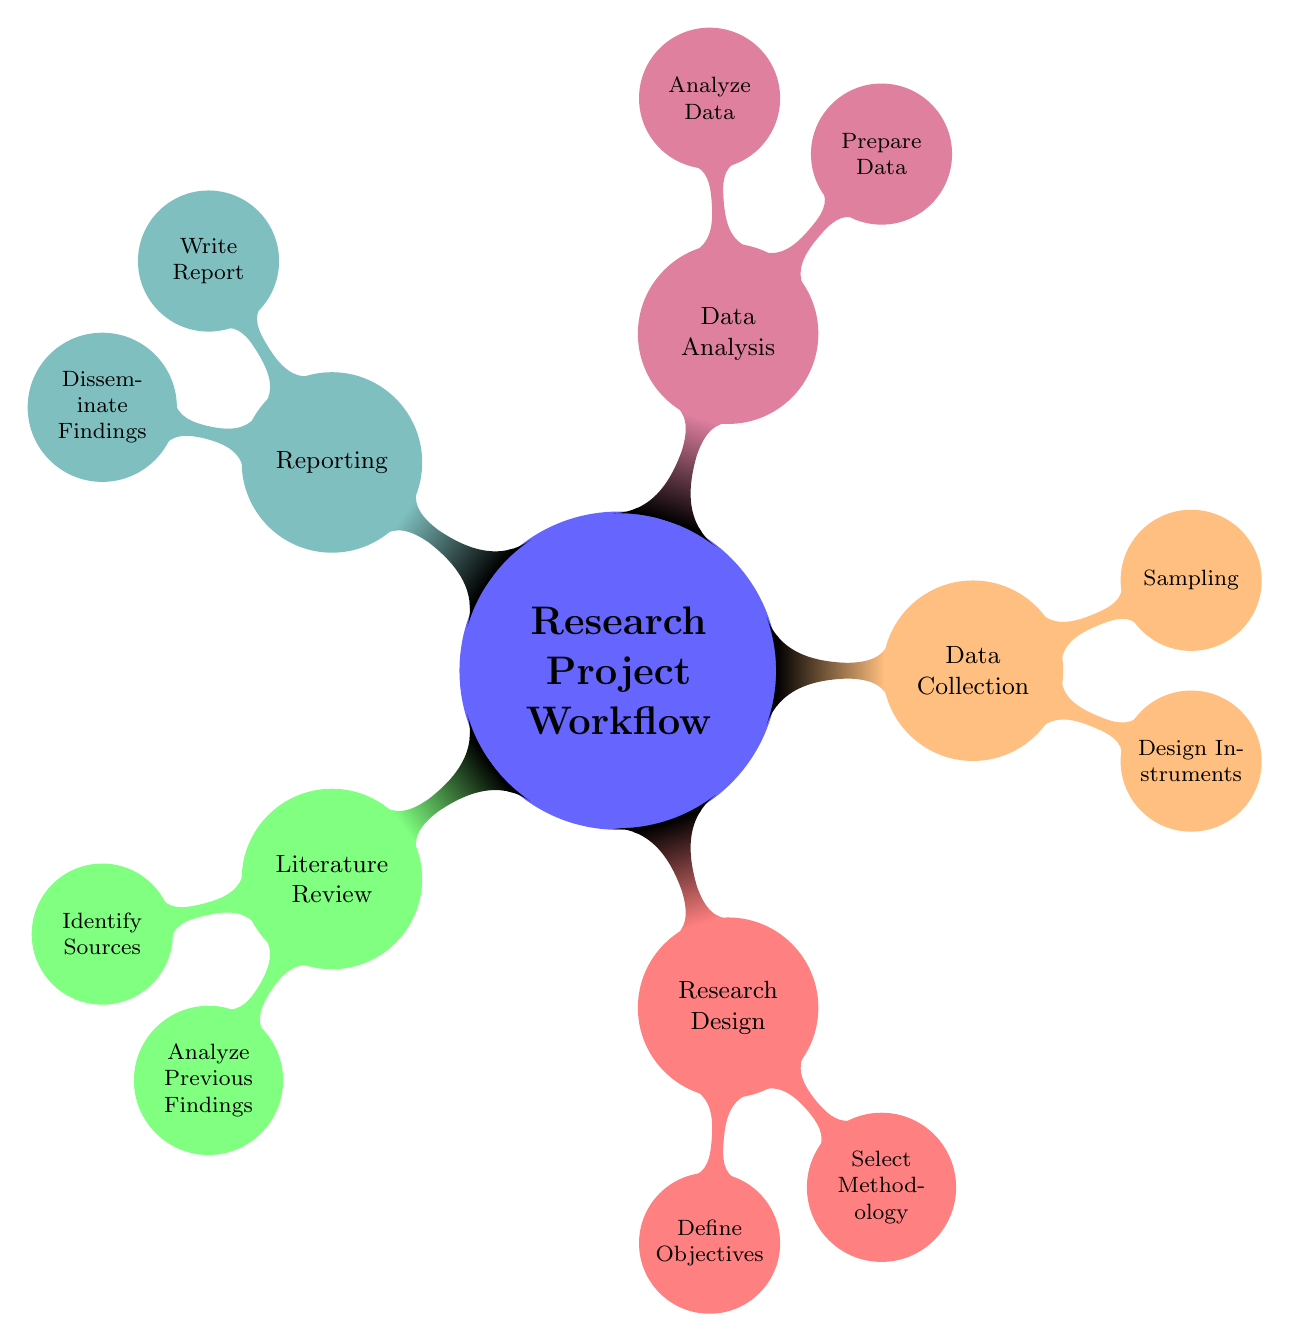What are the two main categories under the Literature Review? The diagram shows "Identify Sources" and "Analyze Previous Findings" as the two child nodes under "Literature Review".
Answer: Identify Sources, Analyze Previous Findings How many nodes are there in the Research Design section? Counting the nodes, the Research Design section has two child nodes: "Define Objectives" and "Select Methodology".
Answer: 2 What is the first step in the Data Analysis phase? The first child node under the Data Analysis section is "Prepare Data" indicating it is the first step mentioned in the diagram.
Answer: Prepare Data Which method is included in the Select Methodology node? The node "Select Methodology" lists three methods including "Qualitative", "Quantitative", and "Mixed Methods". Each of these methods serves as a child node.
Answer: Qualitative, Quantitative, Mixed Methods Which section includes creating instruments for data collection? The node "Design Instruments" is part of the "Data Collection" section, indicating it refers to the creation of tools for gathering data.
Answer: Data Collection What is the primary output of the Reporting section? The final child node under "Reporting" can be interpreted as the concrete outputs, which are the different ways findings can be shared: "Publish in Journals", "Present at Conferences", and "Share with Stakeholders".
Answer: Disseminate Findings In which section can you find "Summarize Key Points"? The activity "Summarize Key Points" is listed as a child under "Analyze Previous Findings", which is part of the "Literature Review" section.
Answer: Literature Review Which two actions are performed during the Data Collection phase? The two child nodes under "Data Collection" are "Design Instruments" and "Sampling", indicating the two primary actions performed at this stage.
Answer: Design Instruments, Sampling 